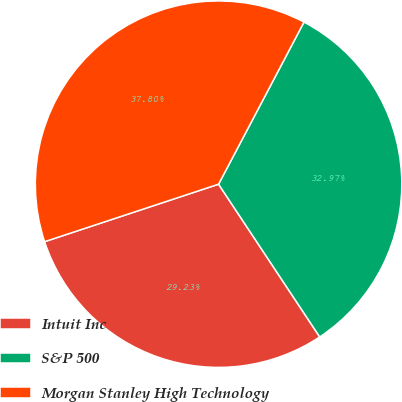Convert chart. <chart><loc_0><loc_0><loc_500><loc_500><pie_chart><fcel>Intuit Inc<fcel>S&P 500<fcel>Morgan Stanley High Technology<nl><fcel>29.23%<fcel>32.97%<fcel>37.8%<nl></chart> 